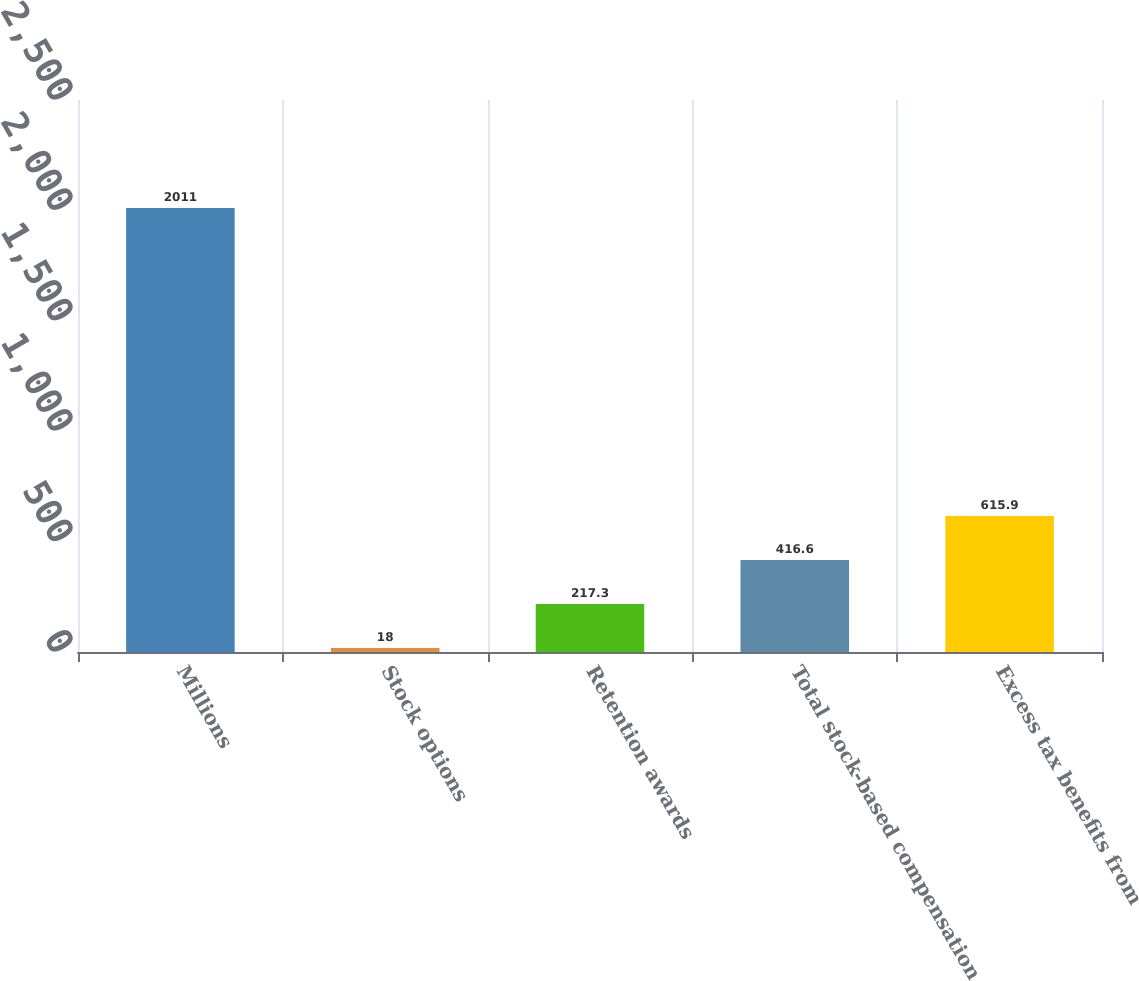<chart> <loc_0><loc_0><loc_500><loc_500><bar_chart><fcel>Millions<fcel>Stock options<fcel>Retention awards<fcel>Total stock-based compensation<fcel>Excess tax benefits from<nl><fcel>2011<fcel>18<fcel>217.3<fcel>416.6<fcel>615.9<nl></chart> 